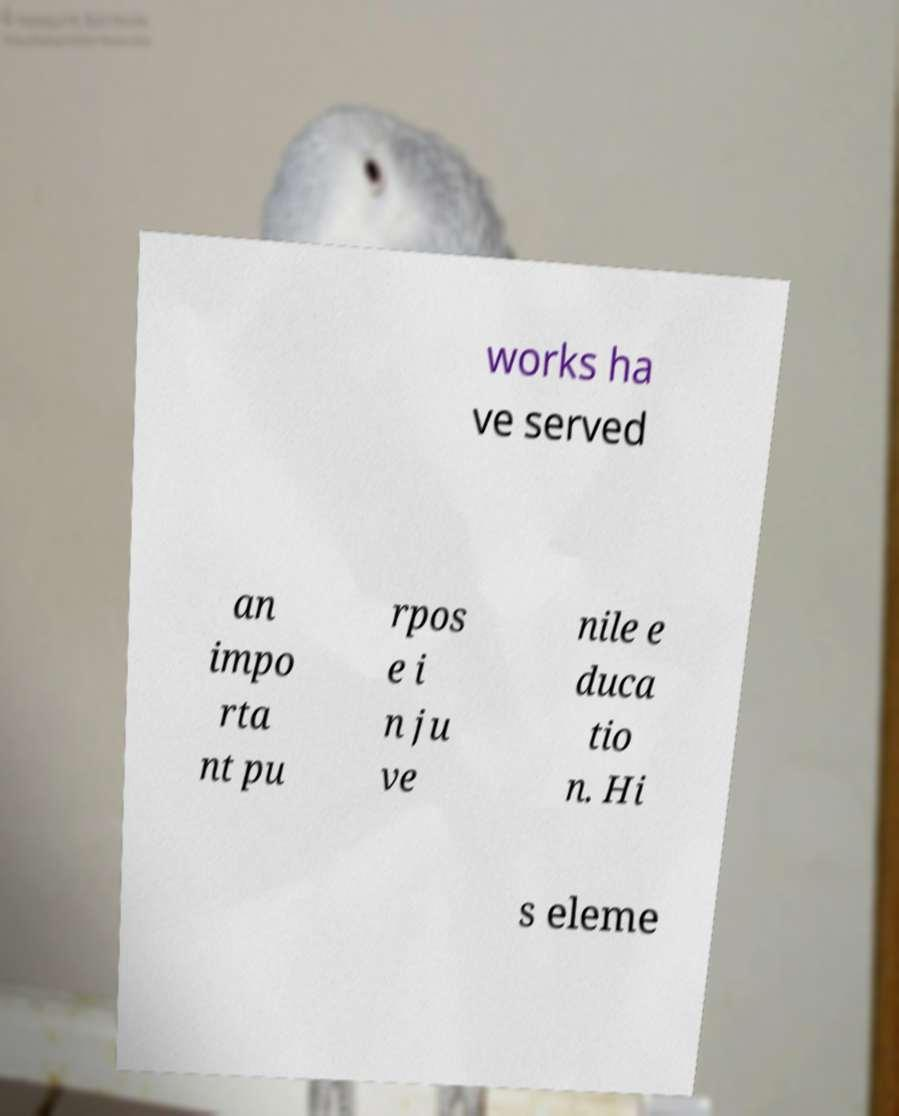Please read and relay the text visible in this image. What does it say? works ha ve served an impo rta nt pu rpos e i n ju ve nile e duca tio n. Hi s eleme 